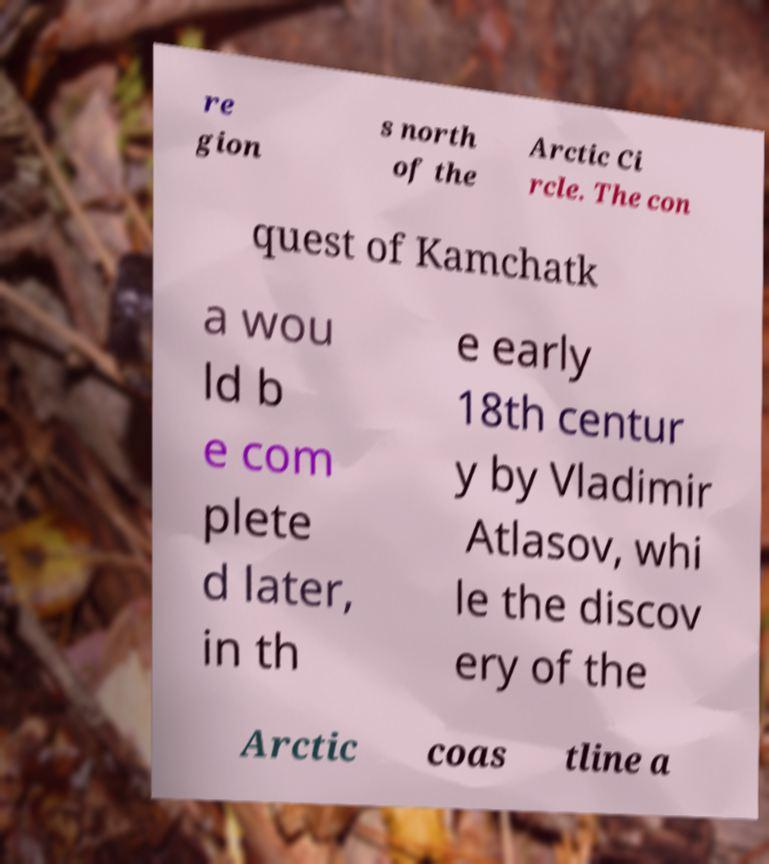Please identify and transcribe the text found in this image. re gion s north of the Arctic Ci rcle. The con quest of Kamchatk a wou ld b e com plete d later, in th e early 18th centur y by Vladimir Atlasov, whi le the discov ery of the Arctic coas tline a 